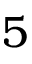Convert formula to latex. <formula><loc_0><loc_0><loc_500><loc_500>5</formula> 